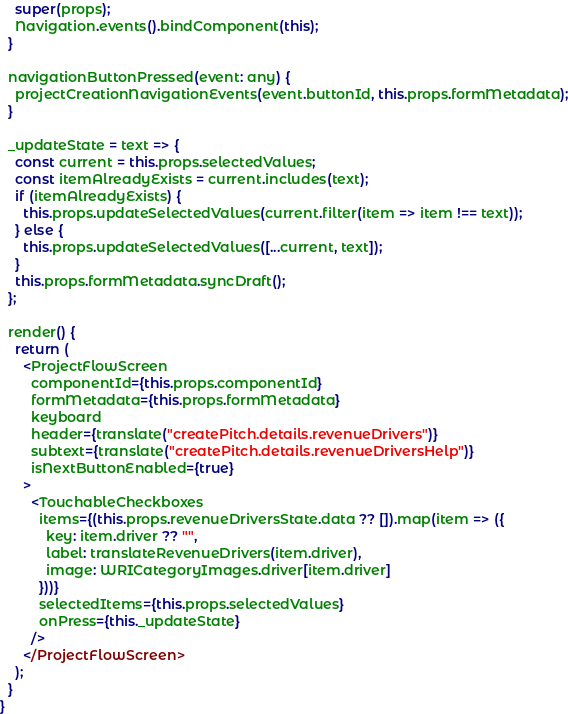Convert code to text. <code><loc_0><loc_0><loc_500><loc_500><_JavaScript_>    super(props);
    Navigation.events().bindComponent(this);
  }

  navigationButtonPressed(event: any) {
    projectCreationNavigationEvents(event.buttonId, this.props.formMetadata);
  }

  _updateState = text => {
    const current = this.props.selectedValues;
    const itemAlreadyExists = current.includes(text);
    if (itemAlreadyExists) {
      this.props.updateSelectedValues(current.filter(item => item !== text));
    } else {
      this.props.updateSelectedValues([...current, text]);
    }
    this.props.formMetadata.syncDraft();
  };

  render() {
    return (
      <ProjectFlowScreen
        componentId={this.props.componentId}
        formMetadata={this.props.formMetadata}
        keyboard
        header={translate("createPitch.details.revenueDrivers")}
        subtext={translate("createPitch.details.revenueDriversHelp")}
        isNextButtonEnabled={true}
      >
        <TouchableCheckboxes
          items={(this.props.revenueDriversState.data ?? []).map(item => ({
            key: item.driver ?? "",
            label: translateRevenueDrivers(item.driver),
            image: WRICategoryImages.driver[item.driver]
          }))}
          selectedItems={this.props.selectedValues}
          onPress={this._updateState}
        />
      </ProjectFlowScreen>
    );
  }
}
</code> 